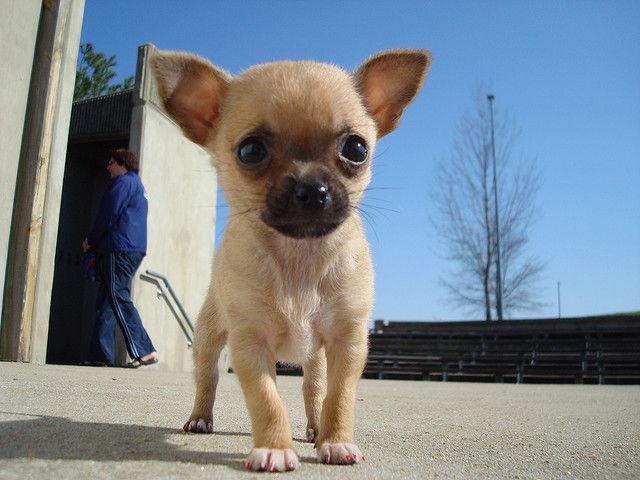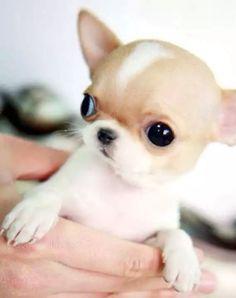The first image is the image on the left, the second image is the image on the right. Given the left and right images, does the statement "An image shows a teacup puppy held by a human hand." hold true? Answer yes or no. Yes. The first image is the image on the left, the second image is the image on the right. Evaluate the accuracy of this statement regarding the images: "Someone is holding the dog on the right.". Is it true? Answer yes or no. Yes. 